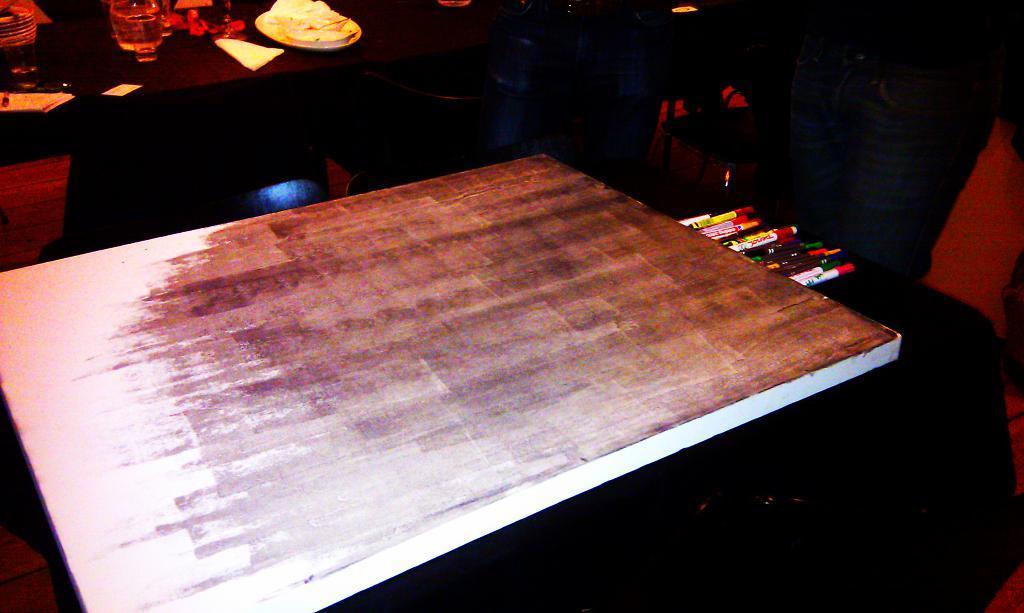Can you describe this image briefly? In the center of the image there is a table. On the right side of the image we can see pens and markers placed on the chair. In the background we can see table, glass and water in jar. 